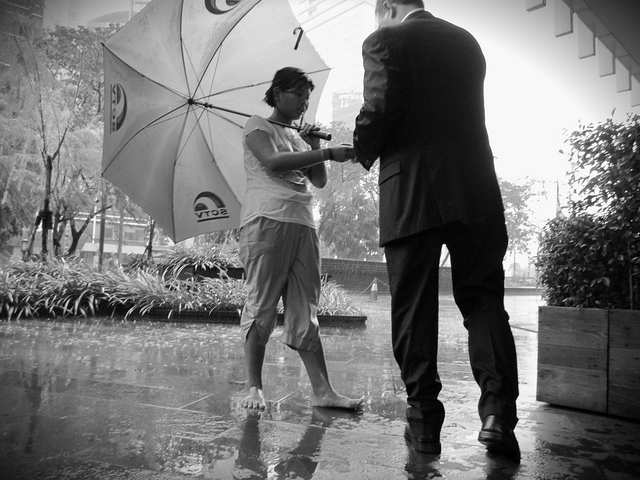Please identify all text content in this image. SCTV 